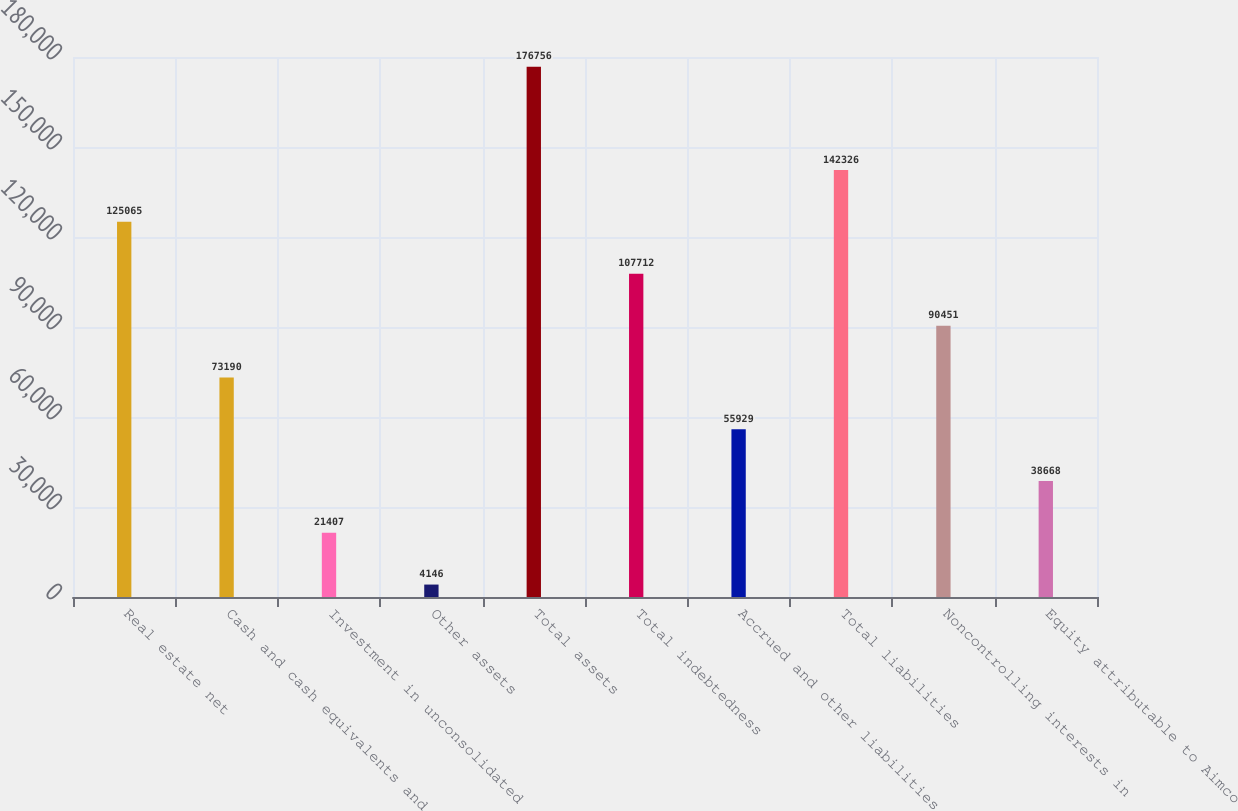Convert chart to OTSL. <chart><loc_0><loc_0><loc_500><loc_500><bar_chart><fcel>Real estate net<fcel>Cash and cash equivalents and<fcel>Investment in unconsolidated<fcel>Other assets<fcel>Total assets<fcel>Total indebtedness<fcel>Accrued and other liabilities<fcel>Total liabilities<fcel>Noncontrolling interests in<fcel>Equity attributable to Aimco<nl><fcel>125065<fcel>73190<fcel>21407<fcel>4146<fcel>176756<fcel>107712<fcel>55929<fcel>142326<fcel>90451<fcel>38668<nl></chart> 